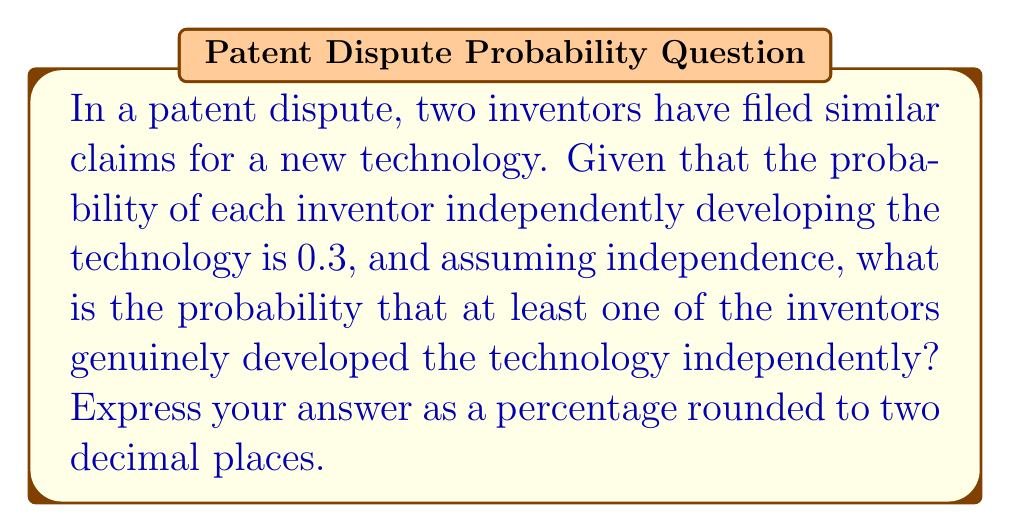What is the answer to this math problem? Let's approach this step-by-step:

1) Let A be the event that the first inventor developed the technology independently, and B be the event that the second inventor developed the technology independently.

2) We're given that P(A) = P(B) = 0.3

3) We want to find the probability that at least one of the inventors developed the technology independently. This is equivalent to the probability that not both inventors failed to develop it independently.

4) Mathematically, this can be expressed as:

   P(at least one) = 1 - P(neither)

5) Since the events are independent, the probability of neither inventor developing it independently is:

   P(neither) = P(not A and not B) = P(not A) × P(not B)

6) P(not A) = 1 - P(A) = 1 - 0.3 = 0.7
   P(not B) = 1 - P(B) = 1 - 0.3 = 0.7

7) Therefore:

   P(neither) = 0.7 × 0.7 = 0.49

8) So, the probability of at least one inventor developing it independently is:

   P(at least one) = 1 - 0.49 = 0.51

9) Converting to a percentage and rounding to two decimal places:

   0.51 × 100 = 51.00%
Answer: 51.00% 